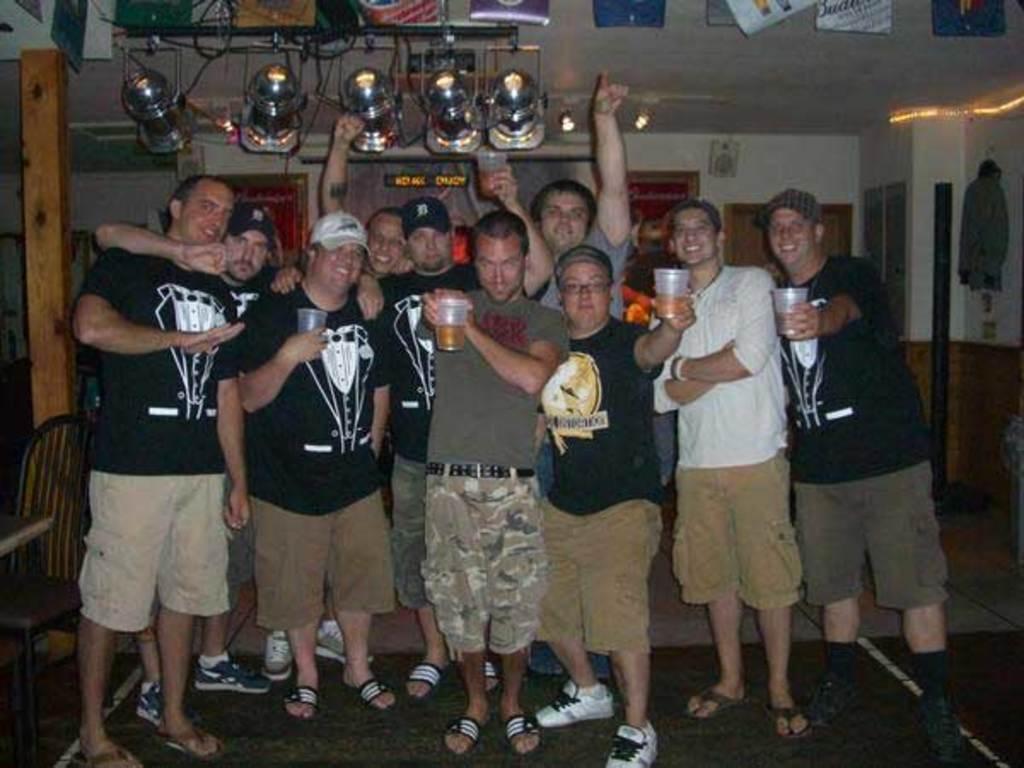Can you describe this image briefly? In this image we can see a few people standing, among them, some are holding the glasses, there are posters and some other objects, also we can see a table and a chair, in the background, we can see some speakers and photo frames on the wall. 